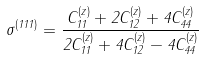<formula> <loc_0><loc_0><loc_500><loc_500>\sigma ^ { ( 1 1 1 ) } = \frac { C ^ { ( z ) } _ { 1 1 } + 2 C ^ { ( z ) } _ { 1 2 } + 4 C ^ { ( z ) } _ { 4 4 } } { 2 C ^ { ( z ) } _ { 1 1 } + 4 C ^ { ( z ) } _ { 1 2 } - 4 C ^ { ( z ) } _ { 4 4 } }</formula> 